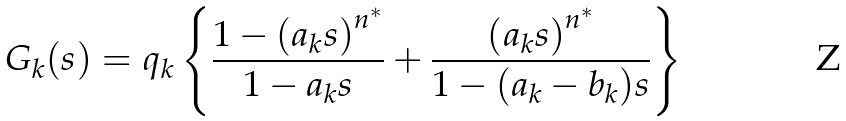<formula> <loc_0><loc_0><loc_500><loc_500>G _ { k } ( s ) = q _ { k } \left \{ \frac { 1 - { ( a _ { k } s ) } ^ { n ^ { * } } } { 1 - a _ { k } s } + \frac { { ( a _ { k } s ) } ^ { n ^ { * } } } { 1 - ( a _ { k } - b _ { k } ) s } \right \}</formula> 